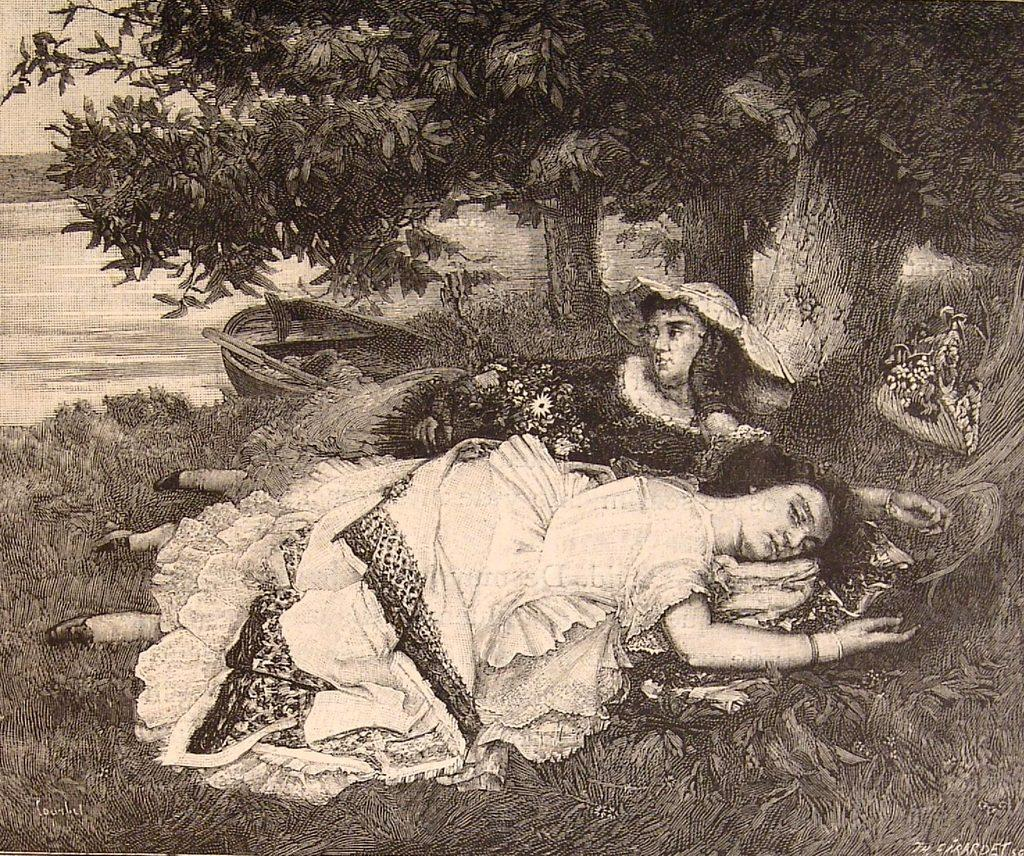What can be seen in the image? There is a poster in the image. What is depicted on the poster? The poster contains images. Where is the boundary between the images on the poster? There is no boundary between the images on the poster mentioned in the facts; the poster simply contains images. 